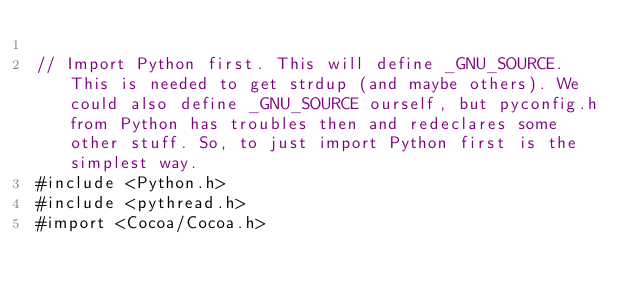<code> <loc_0><loc_0><loc_500><loc_500><_ObjectiveC_>
// Import Python first. This will define _GNU_SOURCE. This is needed to get strdup (and maybe others). We could also define _GNU_SOURCE ourself, but pyconfig.h from Python has troubles then and redeclares some other stuff. So, to just import Python first is the simplest way.
#include <Python.h>
#include <pythread.h>
#import <Cocoa/Cocoa.h></code> 